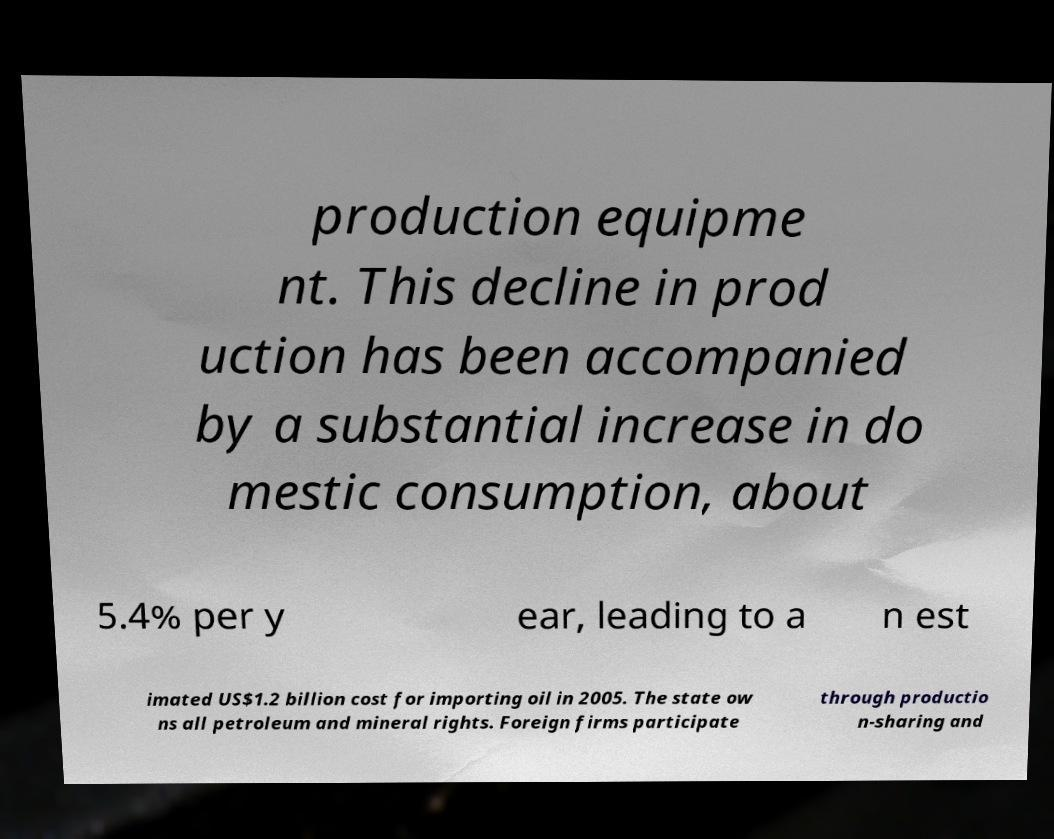Can you accurately transcribe the text from the provided image for me? production equipme nt. This decline in prod uction has been accompanied by a substantial increase in do mestic consumption, about 5.4% per y ear, leading to a n est imated US$1.2 billion cost for importing oil in 2005. The state ow ns all petroleum and mineral rights. Foreign firms participate through productio n-sharing and 